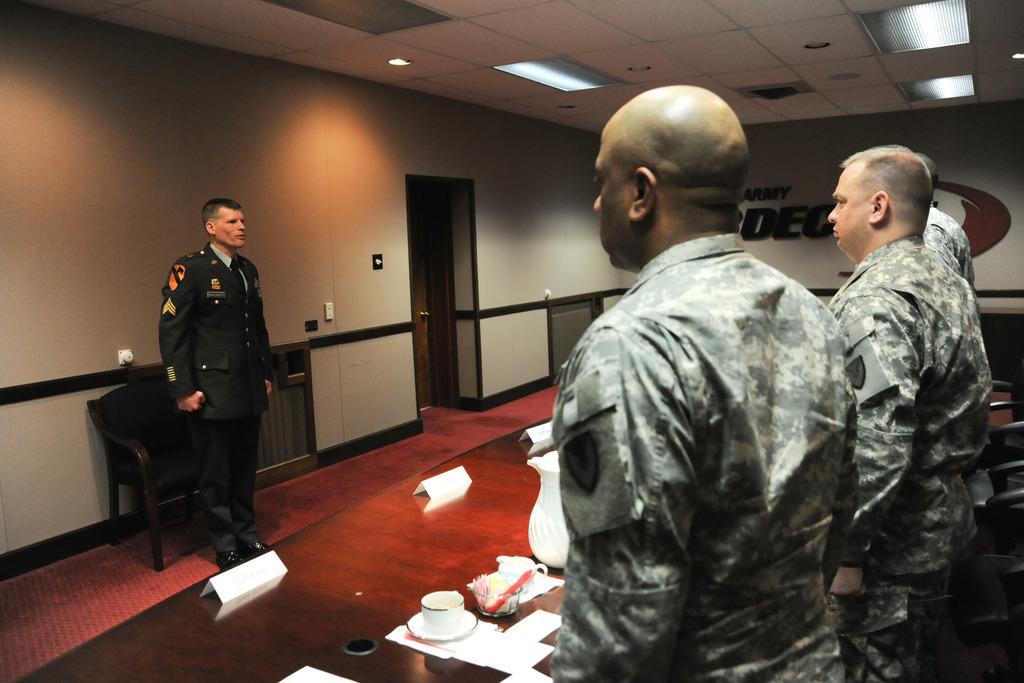How would you summarize this image in a sentence or two? In this image I can see three people with the uniforms. In-front of these people I can see the table. On the table I can see the cupboards, papers, jug and some objects. In the background I can see the chair and the wall. I can also see the lights in the top. 